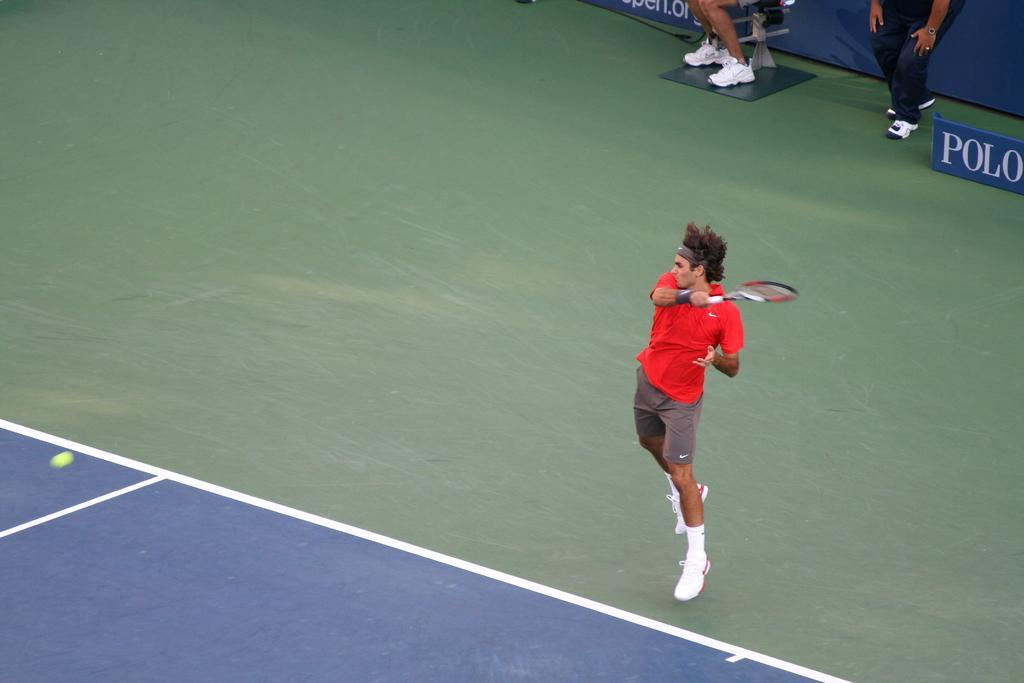Please provide a concise description of this image. In this image in the center there is a man playing holding a bat. In the background there are persons and there are banners with some text written on it. On the left side there is a ball which is green in colour. 